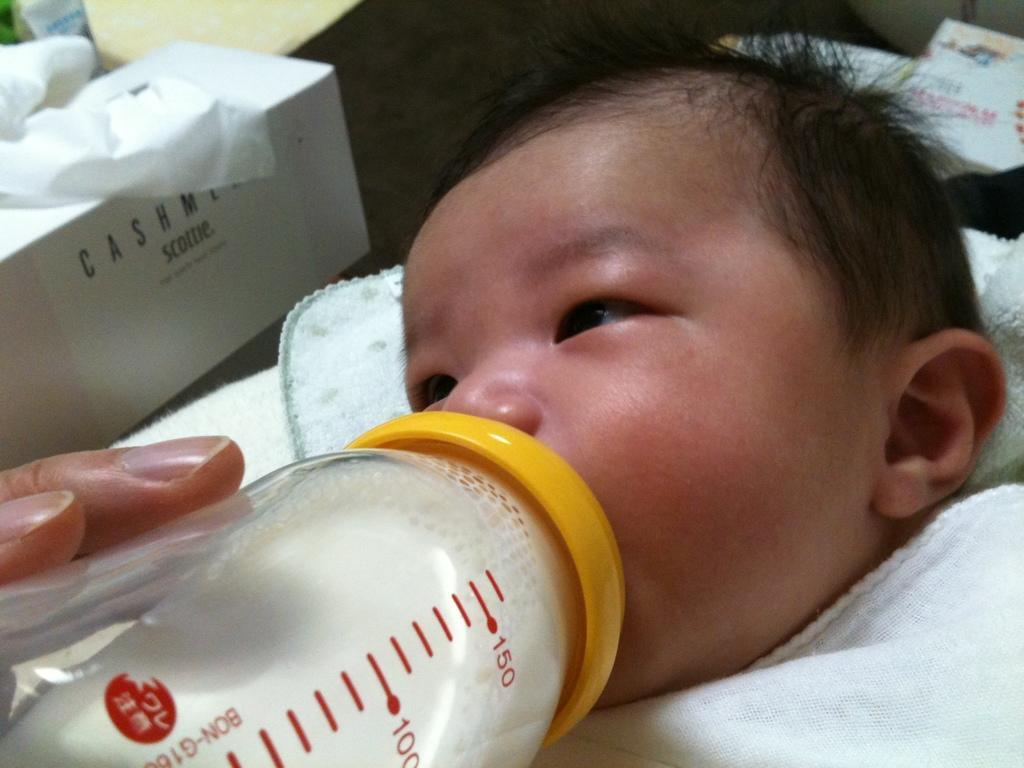Describe this image in one or two sentences. In this picture we can see a baby drinking milk with bottle and cloth is wrapped to that baby and on left side we can see a tissue paper box, this is hand of an person. 